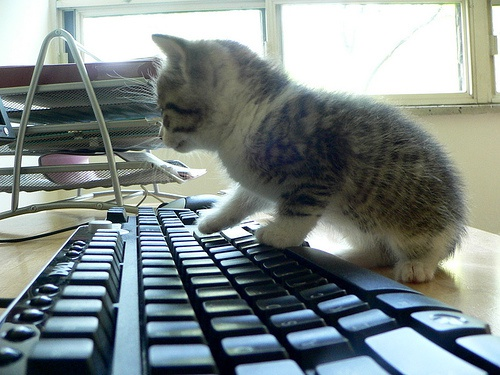Describe the objects in this image and their specific colors. I can see keyboard in ivory, black, lightblue, and gray tones, cat in ivory, gray, black, darkgreen, and darkgray tones, book in ivory, gray, black, and darkgray tones, book in ivory, gray, black, and darkgray tones, and mouse in ivory, white, darkgray, lightblue, and black tones in this image. 